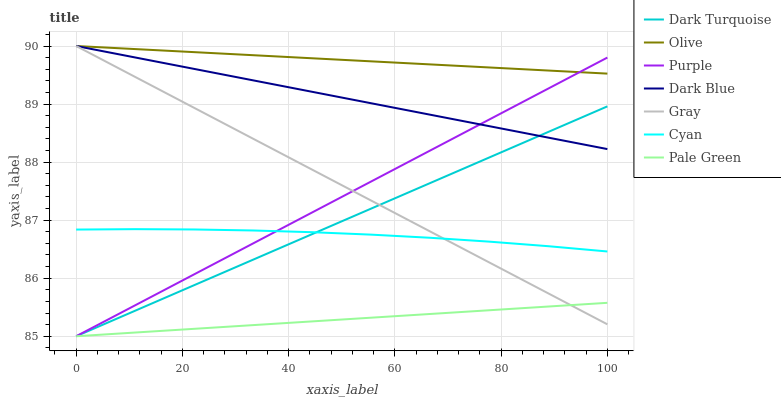Does Pale Green have the minimum area under the curve?
Answer yes or no. Yes. Does Olive have the maximum area under the curve?
Answer yes or no. Yes. Does Purple have the minimum area under the curve?
Answer yes or no. No. Does Purple have the maximum area under the curve?
Answer yes or no. No. Is Dark Blue the smoothest?
Answer yes or no. Yes. Is Cyan the roughest?
Answer yes or no. Yes. Is Purple the smoothest?
Answer yes or no. No. Is Purple the roughest?
Answer yes or no. No. Does Dark Blue have the lowest value?
Answer yes or no. No. Does Olive have the highest value?
Answer yes or no. Yes. Does Purple have the highest value?
Answer yes or no. No. Is Cyan less than Olive?
Answer yes or no. Yes. Is Olive greater than Dark Turquoise?
Answer yes or no. Yes. Does Purple intersect Pale Green?
Answer yes or no. Yes. Is Purple less than Pale Green?
Answer yes or no. No. Is Purple greater than Pale Green?
Answer yes or no. No. Does Cyan intersect Olive?
Answer yes or no. No. 